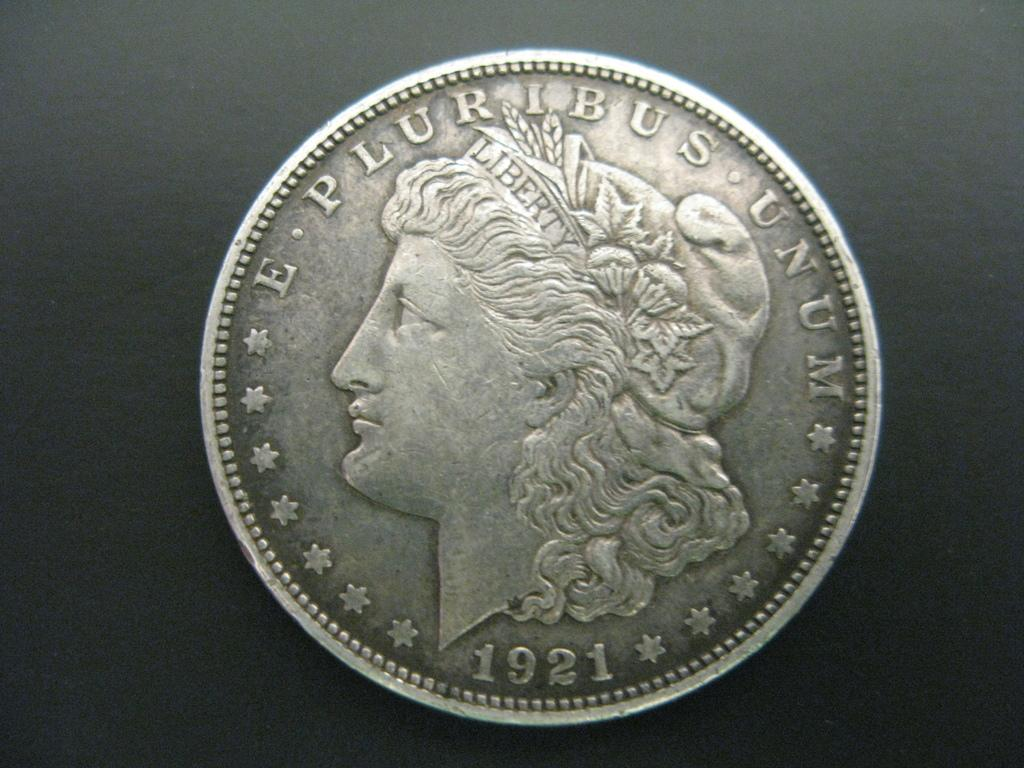<image>
Create a compact narrative representing the image presented. The old silver coin on the grey background was made in 1921. 